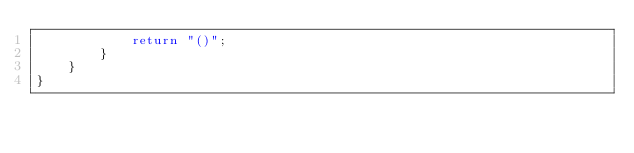Convert code to text. <code><loc_0><loc_0><loc_500><loc_500><_C#_>            return "()";
        }
    }
}
</code> 